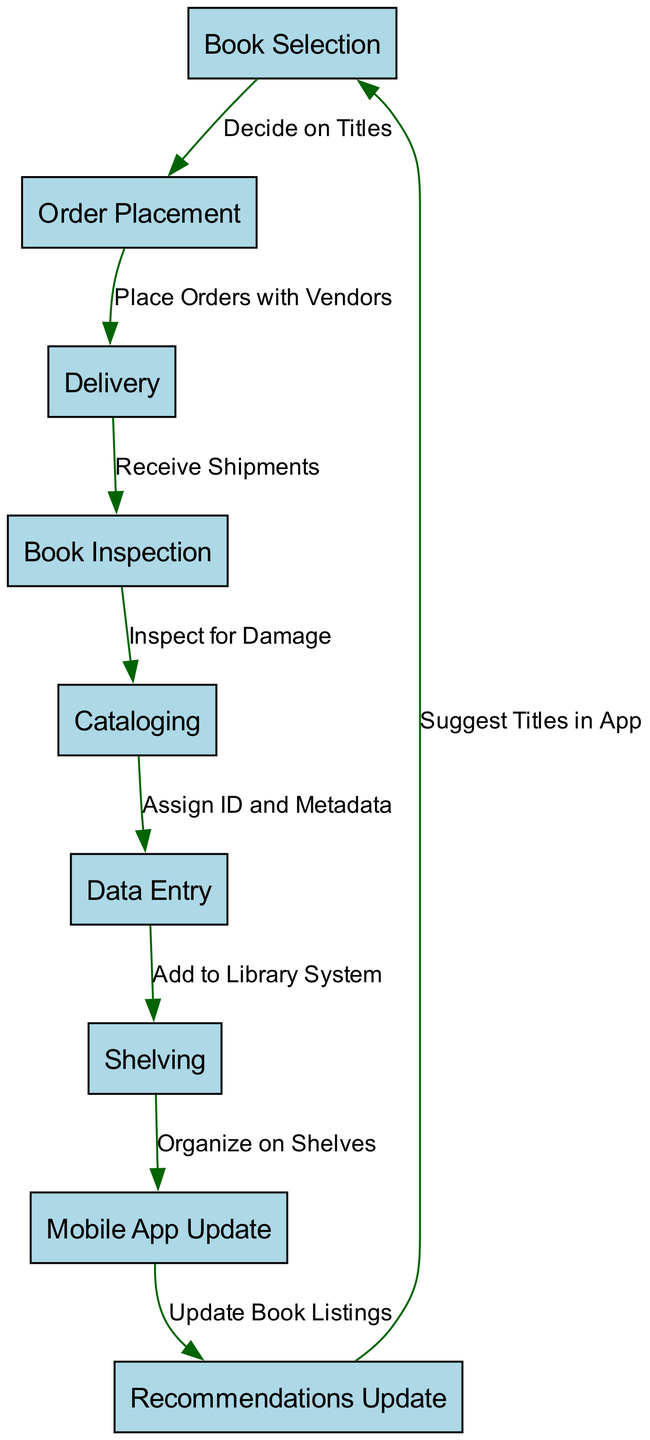What is the first step in the process? The diagram indicates that the first node is labeled "Book Selection," which represents the initial step in acquiring new books for the library.
Answer: Book Selection How many nodes are in the diagram? Upon reviewing the diagram, I count a total of 9 distinct nodes that describe each specific step in the book acquisition and cataloging process.
Answer: 9 What follows after "Delivery"? The diagram shows that the step following "Delivery" is "Book Inspection," which is the next action taken upon receiving the shipments of books.
Answer: Book Inspection What is the last step before updating the mobile app? The last step before "Mobile App Update" is "Shelving," where the newly acquired books are organized and placed on shelves in the library.
Answer: Shelving Which node represents the final recommendation update? The diagram shows that the node labeled "Recommendations Update" is the last in the flow, indicating that this step follows the update of book listings in the mobile application.
Answer: Recommendations Update How does "Cataloging" relate to "Data Entry"? In the diagram, "Cataloging" precedes "Data Entry," meaning that after the cataloging is complete, data about the books is entered into the library system.
Answer: Cataloging How many edges are there in the diagram? A review of the connections between nodes reveals there are 8 edges, representing the relationships and flow between all steps of the process.
Answer: 8 What action follows after "Inspect for Damage"? According to the diagram, "Inspect for Damage" leads directly to "Cataloging," indicating that once the inspection is complete, the next action is to catalog the books.
Answer: Cataloging 